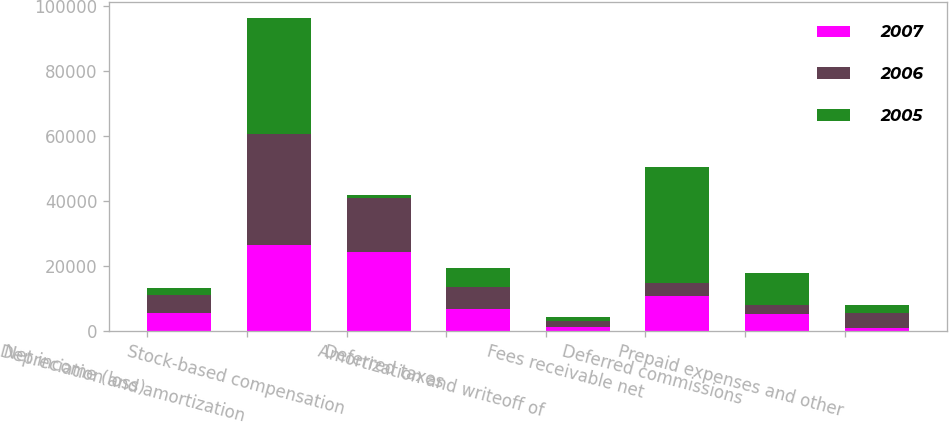<chart> <loc_0><loc_0><loc_500><loc_500><stacked_bar_chart><ecel><fcel>Net income (loss)<fcel>Depreciation and amortization<fcel>Stock-based compensation<fcel>Deferred taxes<fcel>Amortization and writeoff of<fcel>Fees receivable net<fcel>Deferred commissions<fcel>Prepaid expenses and other<nl><fcel>2007<fcel>5455<fcel>26389<fcel>24241<fcel>6740<fcel>1363<fcel>10880<fcel>5266<fcel>857<nl><fcel>2006<fcel>5455<fcel>34197<fcel>16660<fcel>6830<fcel>1627<fcel>3876<fcel>2774<fcel>4562<nl><fcel>2005<fcel>2437<fcel>35728<fcel>1030<fcel>5644<fcel>1424<fcel>35746<fcel>9850<fcel>2436<nl></chart> 